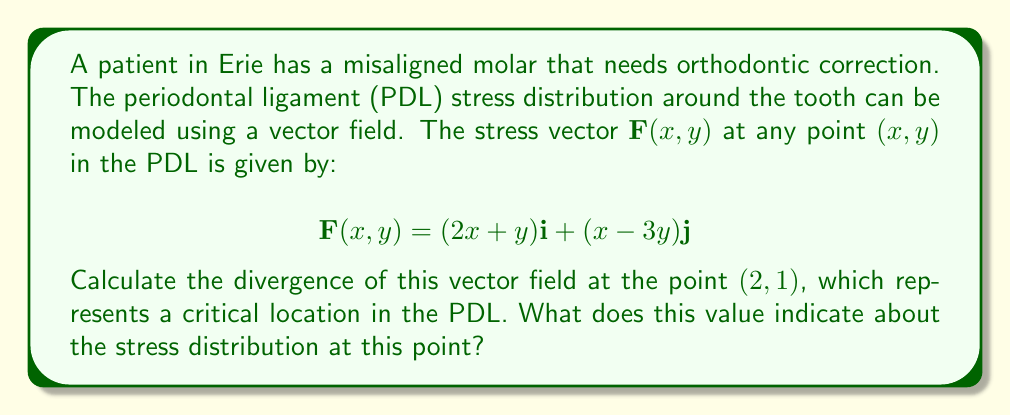Teach me how to tackle this problem. To solve this problem, we need to follow these steps:

1) The divergence of a vector field $\mathbf{F}(x,y) = P(x,y)\mathbf{i} + Q(x,y)\mathbf{j}$ is given by:

   $$\text{div}\mathbf{F} = \nabla \cdot \mathbf{F} = \frac{\partial P}{\partial x} + \frac{\partial Q}{\partial y}$$

2) In our case, $P(x,y) = 2x+y$ and $Q(x,y) = x-3y$

3) Calculate $\frac{\partial P}{\partial x}$:
   $$\frac{\partial P}{\partial x} = \frac{\partial}{\partial x}(2x+y) = 2$$

4) Calculate $\frac{\partial Q}{\partial y}$:
   $$\frac{\partial Q}{\partial y} = \frac{\partial}{\partial y}(x-3y) = -3$$

5) Now, we can calculate the divergence:
   $$\text{div}\mathbf{F} = \frac{\partial P}{\partial x} + \frac{\partial Q}{\partial y} = 2 + (-3) = -1$$

6) This value is constant for all points in the field, including our point of interest (2,1).

7) Interpretation: The negative divergence indicates that this point is a sink in the vector field. In the context of PDL stress, this suggests that stress is converging or accumulating at this point, which could indicate a area of higher stress concentration in the periodontal ligament.
Answer: $-1$; indicates stress convergence/accumulation point in PDL 